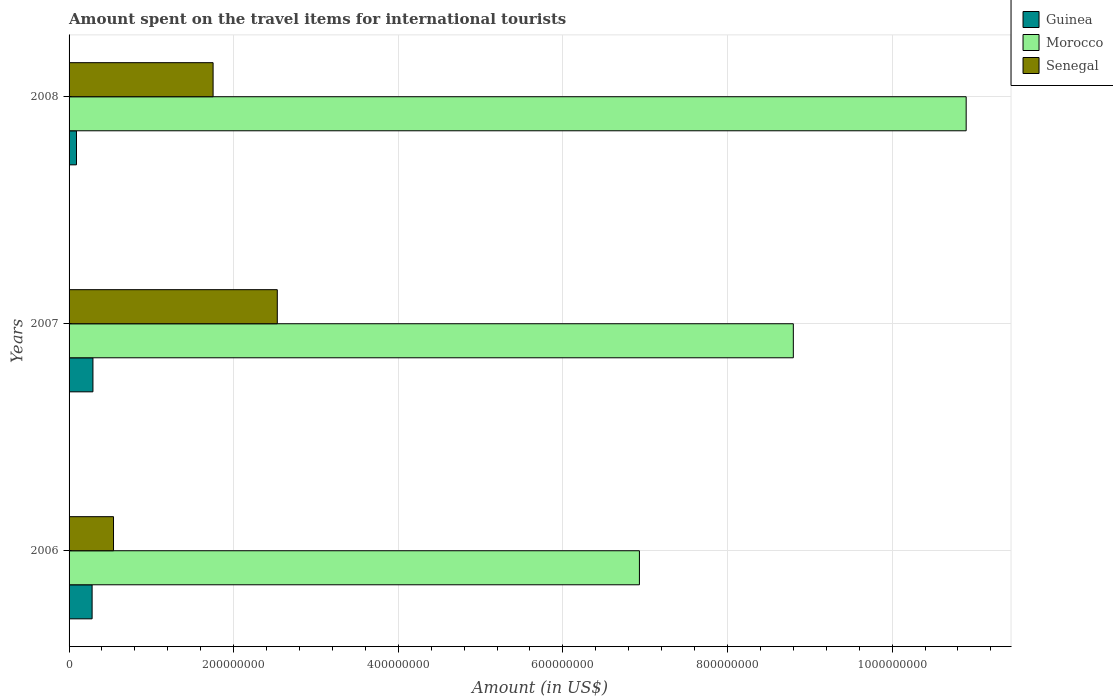How many different coloured bars are there?
Provide a short and direct response. 3. Are the number of bars on each tick of the Y-axis equal?
Offer a very short reply. Yes. What is the label of the 3rd group of bars from the top?
Your answer should be compact. 2006. In how many cases, is the number of bars for a given year not equal to the number of legend labels?
Your answer should be compact. 0. What is the amount spent on the travel items for international tourists in Morocco in 2008?
Offer a terse response. 1.09e+09. Across all years, what is the maximum amount spent on the travel items for international tourists in Morocco?
Provide a short and direct response. 1.09e+09. Across all years, what is the minimum amount spent on the travel items for international tourists in Guinea?
Ensure brevity in your answer.  9.00e+06. In which year was the amount spent on the travel items for international tourists in Senegal maximum?
Provide a succinct answer. 2007. In which year was the amount spent on the travel items for international tourists in Senegal minimum?
Provide a succinct answer. 2006. What is the total amount spent on the travel items for international tourists in Senegal in the graph?
Give a very brief answer. 4.82e+08. What is the difference between the amount spent on the travel items for international tourists in Senegal in 2006 and that in 2008?
Your answer should be very brief. -1.21e+08. What is the difference between the amount spent on the travel items for international tourists in Morocco in 2006 and the amount spent on the travel items for international tourists in Guinea in 2007?
Keep it short and to the point. 6.64e+08. What is the average amount spent on the travel items for international tourists in Guinea per year?
Give a very brief answer. 2.20e+07. In the year 2008, what is the difference between the amount spent on the travel items for international tourists in Senegal and amount spent on the travel items for international tourists in Morocco?
Your response must be concise. -9.15e+08. In how many years, is the amount spent on the travel items for international tourists in Guinea greater than 520000000 US$?
Provide a short and direct response. 0. What is the ratio of the amount spent on the travel items for international tourists in Morocco in 2006 to that in 2007?
Provide a short and direct response. 0.79. Is the difference between the amount spent on the travel items for international tourists in Senegal in 2006 and 2008 greater than the difference between the amount spent on the travel items for international tourists in Morocco in 2006 and 2008?
Your answer should be compact. Yes. What is the difference between the highest and the second highest amount spent on the travel items for international tourists in Senegal?
Your answer should be very brief. 7.80e+07. What is the difference between the highest and the lowest amount spent on the travel items for international tourists in Senegal?
Ensure brevity in your answer.  1.99e+08. In how many years, is the amount spent on the travel items for international tourists in Morocco greater than the average amount spent on the travel items for international tourists in Morocco taken over all years?
Your response must be concise. 1. Is the sum of the amount spent on the travel items for international tourists in Morocco in 2006 and 2007 greater than the maximum amount spent on the travel items for international tourists in Guinea across all years?
Your answer should be very brief. Yes. What does the 1st bar from the top in 2007 represents?
Provide a short and direct response. Senegal. What does the 1st bar from the bottom in 2008 represents?
Make the answer very short. Guinea. Are the values on the major ticks of X-axis written in scientific E-notation?
Make the answer very short. No. Does the graph contain any zero values?
Offer a terse response. No. Where does the legend appear in the graph?
Give a very brief answer. Top right. What is the title of the graph?
Make the answer very short. Amount spent on the travel items for international tourists. What is the label or title of the Y-axis?
Offer a terse response. Years. What is the Amount (in US$) of Guinea in 2006?
Provide a succinct answer. 2.80e+07. What is the Amount (in US$) in Morocco in 2006?
Keep it short and to the point. 6.93e+08. What is the Amount (in US$) of Senegal in 2006?
Make the answer very short. 5.40e+07. What is the Amount (in US$) in Guinea in 2007?
Offer a very short reply. 2.90e+07. What is the Amount (in US$) of Morocco in 2007?
Offer a terse response. 8.80e+08. What is the Amount (in US$) of Senegal in 2007?
Ensure brevity in your answer.  2.53e+08. What is the Amount (in US$) in Guinea in 2008?
Your answer should be compact. 9.00e+06. What is the Amount (in US$) in Morocco in 2008?
Your answer should be compact. 1.09e+09. What is the Amount (in US$) of Senegal in 2008?
Offer a very short reply. 1.75e+08. Across all years, what is the maximum Amount (in US$) in Guinea?
Provide a succinct answer. 2.90e+07. Across all years, what is the maximum Amount (in US$) in Morocco?
Provide a short and direct response. 1.09e+09. Across all years, what is the maximum Amount (in US$) of Senegal?
Provide a succinct answer. 2.53e+08. Across all years, what is the minimum Amount (in US$) in Guinea?
Your response must be concise. 9.00e+06. Across all years, what is the minimum Amount (in US$) of Morocco?
Offer a terse response. 6.93e+08. Across all years, what is the minimum Amount (in US$) of Senegal?
Give a very brief answer. 5.40e+07. What is the total Amount (in US$) in Guinea in the graph?
Ensure brevity in your answer.  6.60e+07. What is the total Amount (in US$) of Morocco in the graph?
Make the answer very short. 2.66e+09. What is the total Amount (in US$) in Senegal in the graph?
Provide a succinct answer. 4.82e+08. What is the difference between the Amount (in US$) of Morocco in 2006 and that in 2007?
Offer a terse response. -1.87e+08. What is the difference between the Amount (in US$) in Senegal in 2006 and that in 2007?
Your answer should be compact. -1.99e+08. What is the difference between the Amount (in US$) of Guinea in 2006 and that in 2008?
Offer a very short reply. 1.90e+07. What is the difference between the Amount (in US$) in Morocco in 2006 and that in 2008?
Keep it short and to the point. -3.97e+08. What is the difference between the Amount (in US$) in Senegal in 2006 and that in 2008?
Your response must be concise. -1.21e+08. What is the difference between the Amount (in US$) of Morocco in 2007 and that in 2008?
Provide a short and direct response. -2.10e+08. What is the difference between the Amount (in US$) in Senegal in 2007 and that in 2008?
Your response must be concise. 7.80e+07. What is the difference between the Amount (in US$) in Guinea in 2006 and the Amount (in US$) in Morocco in 2007?
Your answer should be compact. -8.52e+08. What is the difference between the Amount (in US$) of Guinea in 2006 and the Amount (in US$) of Senegal in 2007?
Make the answer very short. -2.25e+08. What is the difference between the Amount (in US$) of Morocco in 2006 and the Amount (in US$) of Senegal in 2007?
Your answer should be compact. 4.40e+08. What is the difference between the Amount (in US$) of Guinea in 2006 and the Amount (in US$) of Morocco in 2008?
Offer a terse response. -1.06e+09. What is the difference between the Amount (in US$) of Guinea in 2006 and the Amount (in US$) of Senegal in 2008?
Give a very brief answer. -1.47e+08. What is the difference between the Amount (in US$) of Morocco in 2006 and the Amount (in US$) of Senegal in 2008?
Make the answer very short. 5.18e+08. What is the difference between the Amount (in US$) in Guinea in 2007 and the Amount (in US$) in Morocco in 2008?
Offer a terse response. -1.06e+09. What is the difference between the Amount (in US$) in Guinea in 2007 and the Amount (in US$) in Senegal in 2008?
Keep it short and to the point. -1.46e+08. What is the difference between the Amount (in US$) in Morocco in 2007 and the Amount (in US$) in Senegal in 2008?
Provide a short and direct response. 7.05e+08. What is the average Amount (in US$) of Guinea per year?
Provide a succinct answer. 2.20e+07. What is the average Amount (in US$) in Morocco per year?
Keep it short and to the point. 8.88e+08. What is the average Amount (in US$) in Senegal per year?
Offer a terse response. 1.61e+08. In the year 2006, what is the difference between the Amount (in US$) in Guinea and Amount (in US$) in Morocco?
Provide a succinct answer. -6.65e+08. In the year 2006, what is the difference between the Amount (in US$) of Guinea and Amount (in US$) of Senegal?
Provide a succinct answer. -2.60e+07. In the year 2006, what is the difference between the Amount (in US$) in Morocco and Amount (in US$) in Senegal?
Make the answer very short. 6.39e+08. In the year 2007, what is the difference between the Amount (in US$) in Guinea and Amount (in US$) in Morocco?
Make the answer very short. -8.51e+08. In the year 2007, what is the difference between the Amount (in US$) of Guinea and Amount (in US$) of Senegal?
Keep it short and to the point. -2.24e+08. In the year 2007, what is the difference between the Amount (in US$) in Morocco and Amount (in US$) in Senegal?
Make the answer very short. 6.27e+08. In the year 2008, what is the difference between the Amount (in US$) in Guinea and Amount (in US$) in Morocco?
Your answer should be compact. -1.08e+09. In the year 2008, what is the difference between the Amount (in US$) of Guinea and Amount (in US$) of Senegal?
Keep it short and to the point. -1.66e+08. In the year 2008, what is the difference between the Amount (in US$) of Morocco and Amount (in US$) of Senegal?
Give a very brief answer. 9.15e+08. What is the ratio of the Amount (in US$) in Guinea in 2006 to that in 2007?
Give a very brief answer. 0.97. What is the ratio of the Amount (in US$) of Morocco in 2006 to that in 2007?
Provide a short and direct response. 0.79. What is the ratio of the Amount (in US$) in Senegal in 2006 to that in 2007?
Offer a very short reply. 0.21. What is the ratio of the Amount (in US$) in Guinea in 2006 to that in 2008?
Give a very brief answer. 3.11. What is the ratio of the Amount (in US$) of Morocco in 2006 to that in 2008?
Ensure brevity in your answer.  0.64. What is the ratio of the Amount (in US$) in Senegal in 2006 to that in 2008?
Your answer should be compact. 0.31. What is the ratio of the Amount (in US$) of Guinea in 2007 to that in 2008?
Offer a terse response. 3.22. What is the ratio of the Amount (in US$) in Morocco in 2007 to that in 2008?
Offer a terse response. 0.81. What is the ratio of the Amount (in US$) of Senegal in 2007 to that in 2008?
Your answer should be compact. 1.45. What is the difference between the highest and the second highest Amount (in US$) of Morocco?
Keep it short and to the point. 2.10e+08. What is the difference between the highest and the second highest Amount (in US$) in Senegal?
Offer a very short reply. 7.80e+07. What is the difference between the highest and the lowest Amount (in US$) in Morocco?
Your answer should be compact. 3.97e+08. What is the difference between the highest and the lowest Amount (in US$) of Senegal?
Your answer should be very brief. 1.99e+08. 